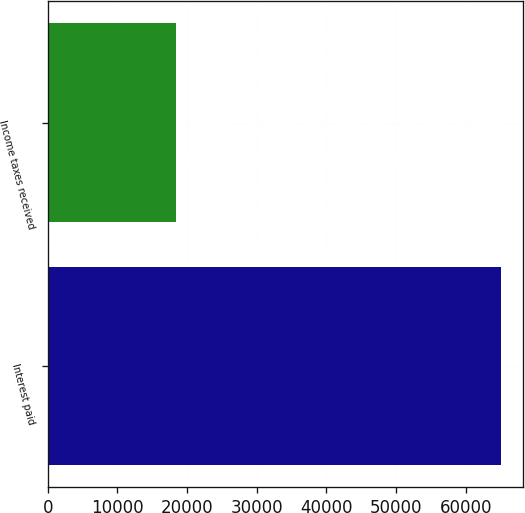<chart> <loc_0><loc_0><loc_500><loc_500><bar_chart><fcel>Interest paid<fcel>Income taxes received<nl><fcel>64997<fcel>18351<nl></chart> 